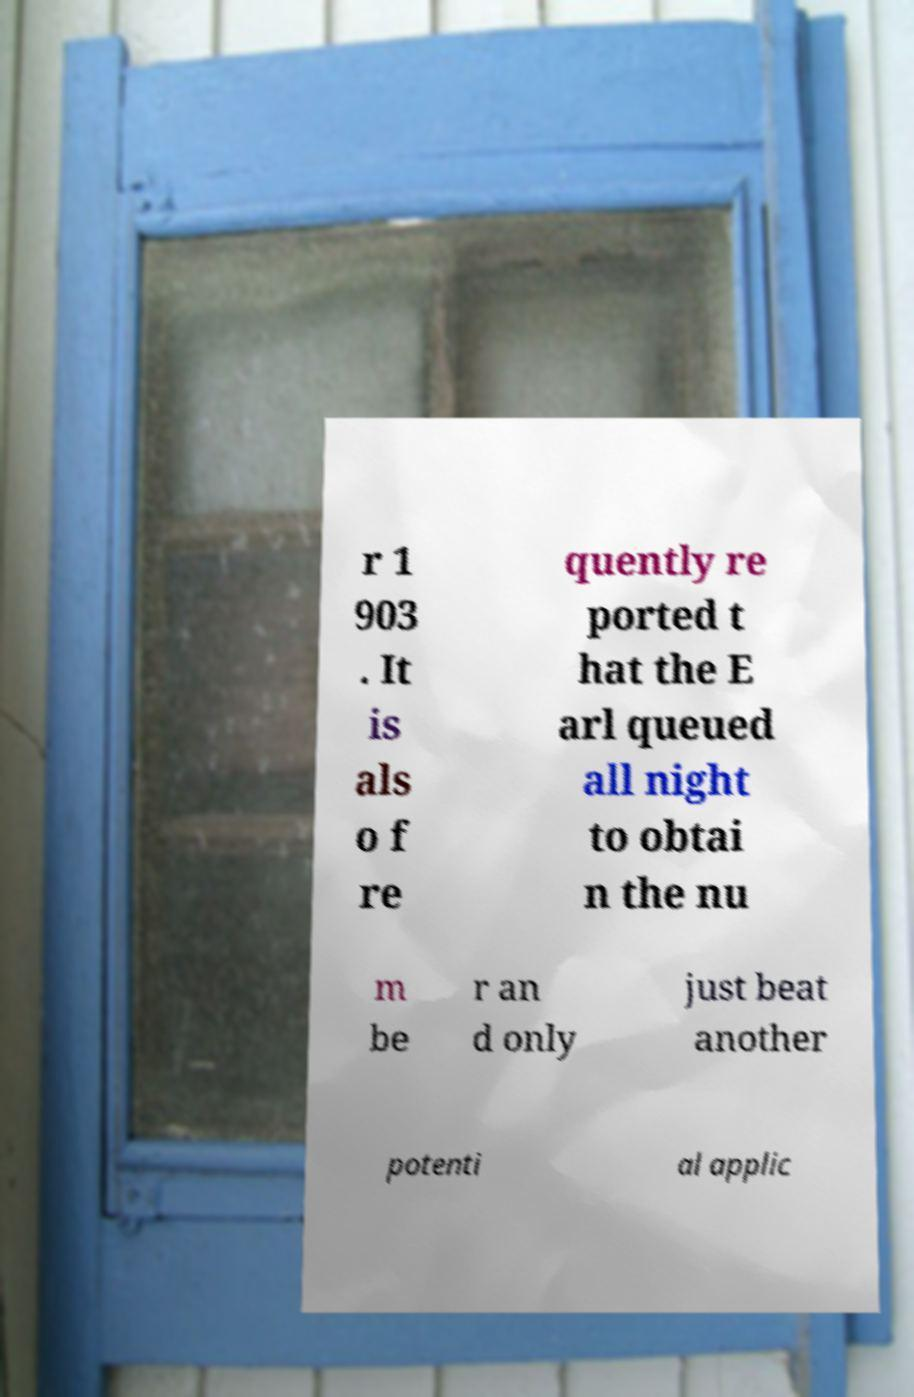Please identify and transcribe the text found in this image. r 1 903 . It is als o f re quently re ported t hat the E arl queued all night to obtai n the nu m be r an d only just beat another potenti al applic 